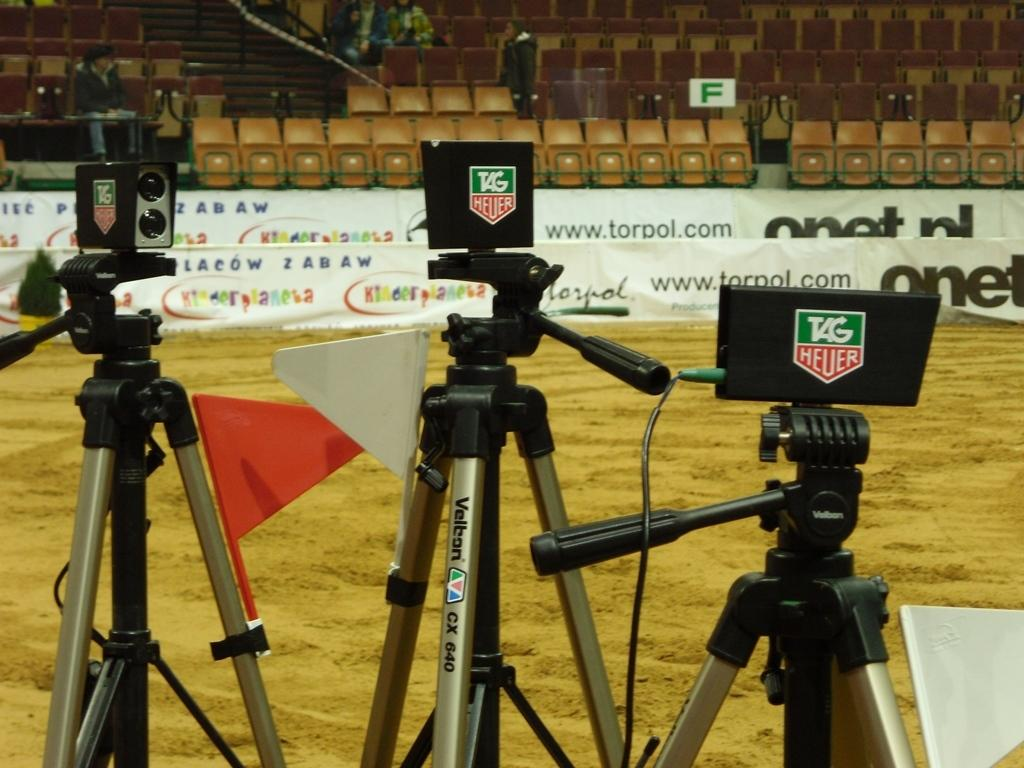What is located in the center of the image? In the center of the image, there are stands, cameras, flags, and a white color object. What can be seen in the background of the image? In the background of the image, there are attached chairs, banners, people, and other objects. What type of powder is being used by the people in the image? There is no powder visible in the image; it features stands, cameras, flags, chairs, banners, and people. Is there a jail present in the image? No, there is no jail present in the image. 